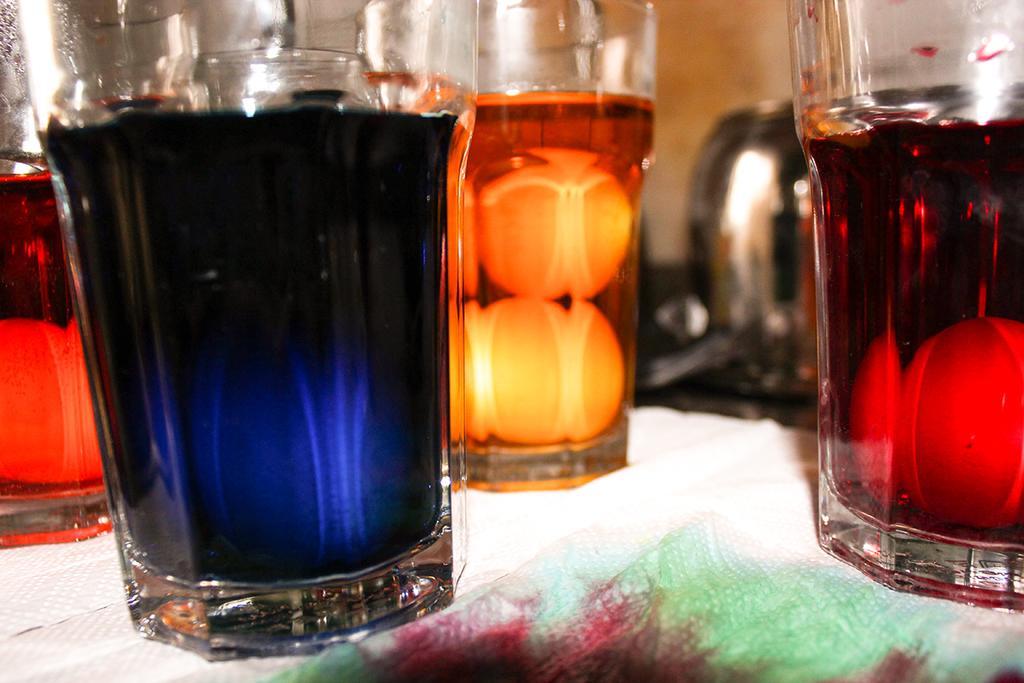Describe this image in one or two sentences. This image consists of few glasses. In which there are drinks in different colors. At the bottom, there is a table covered with a cloth. 